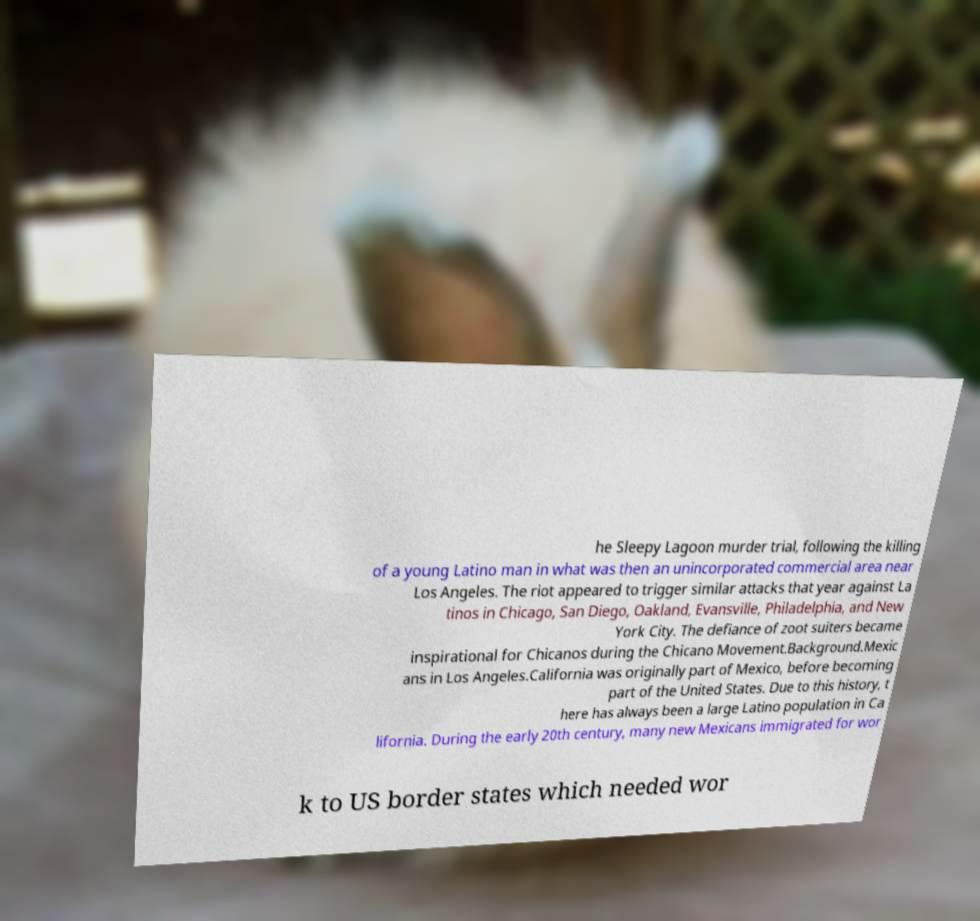For documentation purposes, I need the text within this image transcribed. Could you provide that? he Sleepy Lagoon murder trial, following the killing of a young Latino man in what was then an unincorporated commercial area near Los Angeles. The riot appeared to trigger similar attacks that year against La tinos in Chicago, San Diego, Oakland, Evansville, Philadelphia, and New York City. The defiance of zoot suiters became inspirational for Chicanos during the Chicano Movement.Background.Mexic ans in Los Angeles.California was originally part of Mexico, before becoming part of the United States. Due to this history, t here has always been a large Latino population in Ca lifornia. During the early 20th century, many new Mexicans immigrated for wor k to US border states which needed wor 